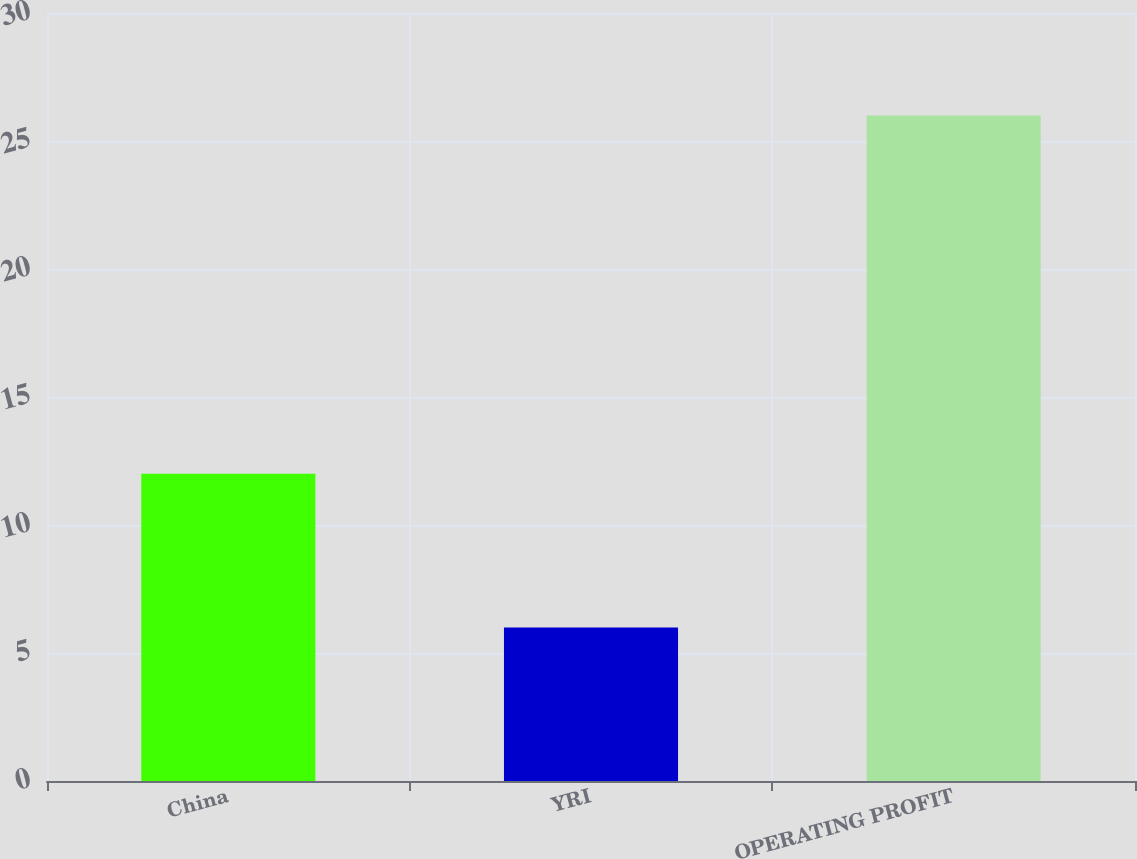<chart> <loc_0><loc_0><loc_500><loc_500><bar_chart><fcel>China<fcel>YRI<fcel>OPERATING PROFIT<nl><fcel>12<fcel>6<fcel>26<nl></chart> 